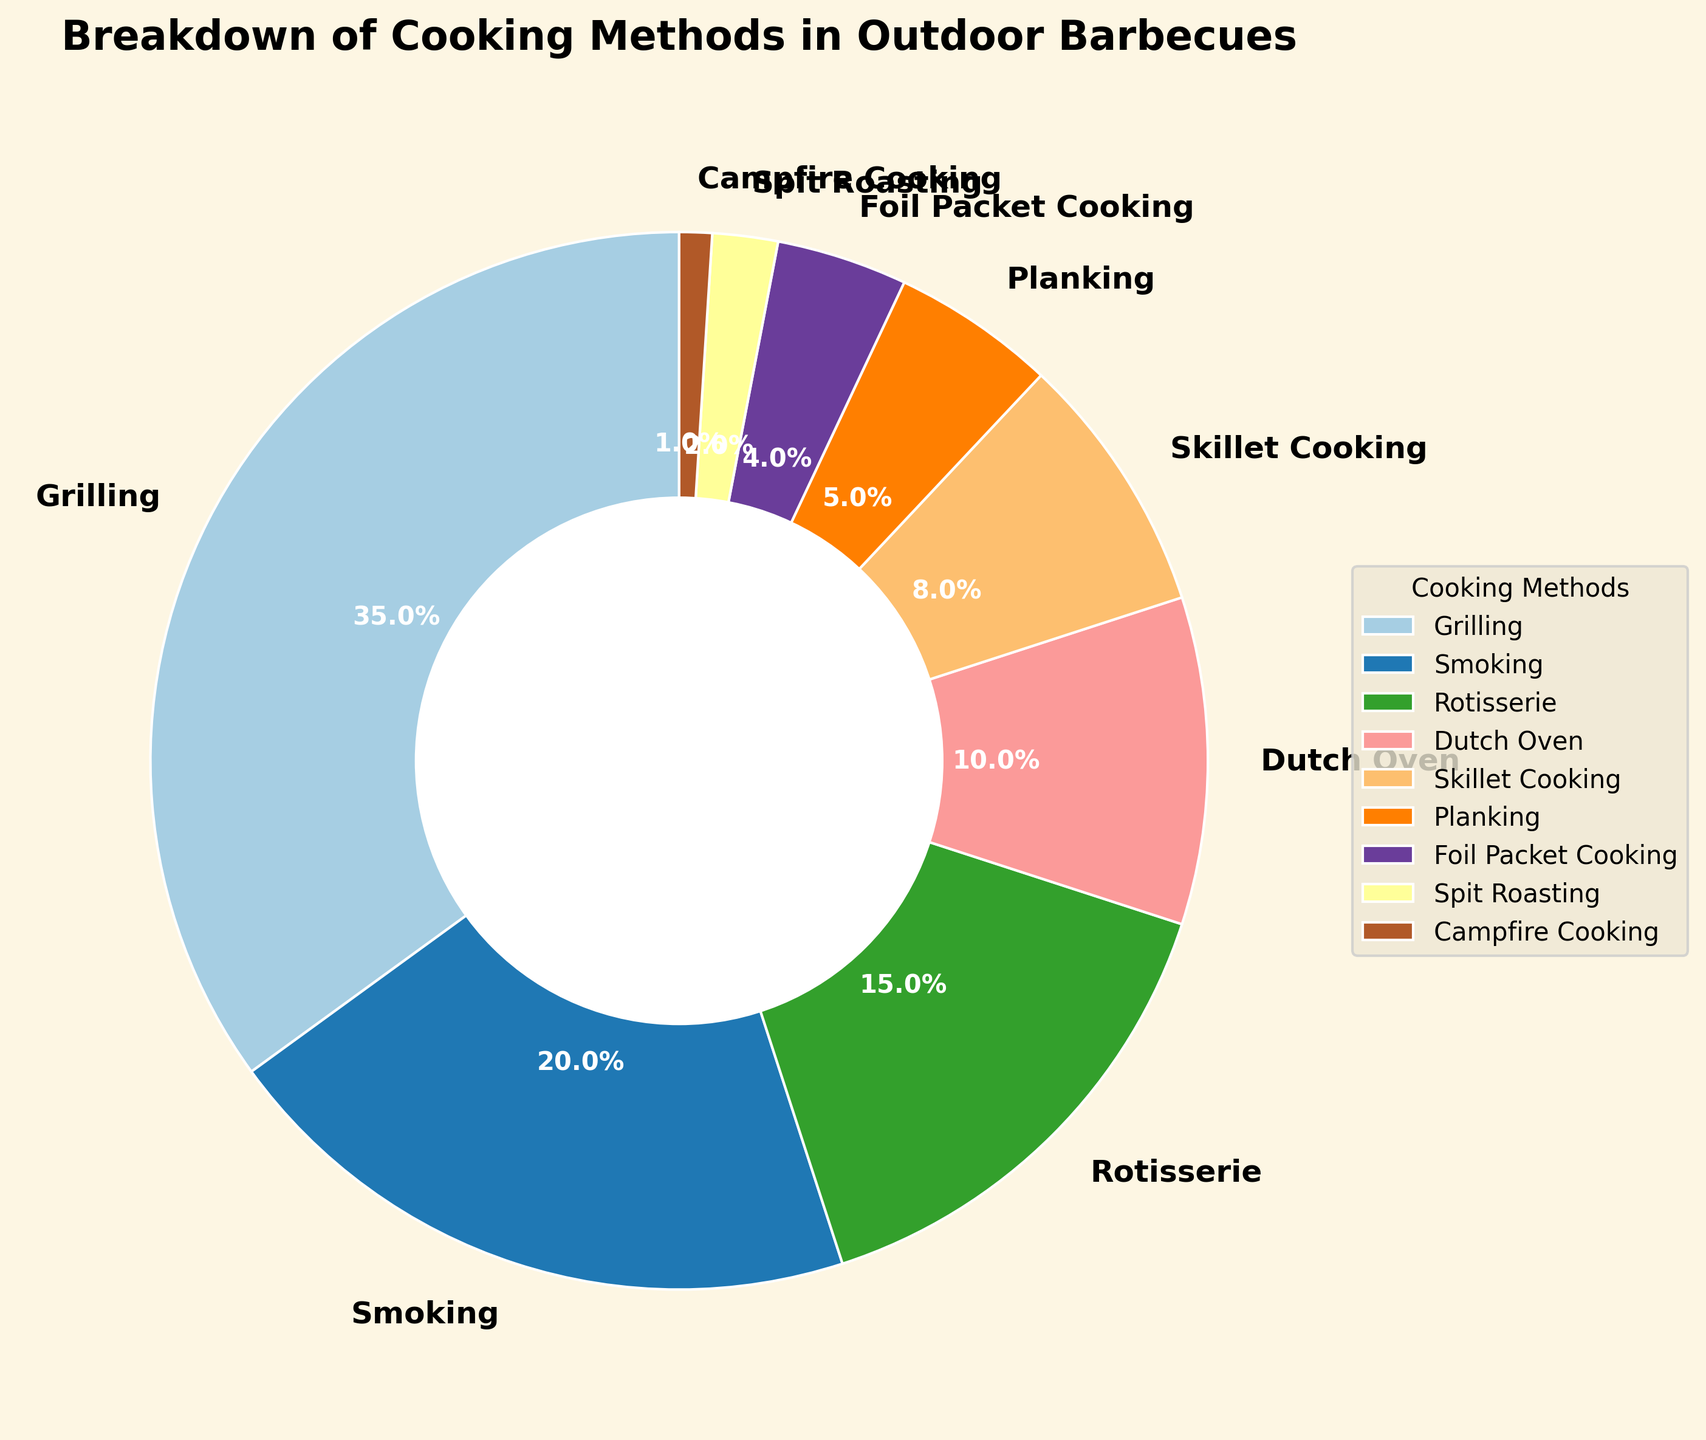Which cooking method is used the most in outdoor barbecues? The cooking method with the largest slice in the pie chart is Grilling, which represents 35%.
Answer: Grilling Which two cooking methods together make up exactly half of the distribution? Summing up the percentages of Grilling (35%) and Smoking (20%) gives us 55%, which exceeds half. Therefore, Grilling (35%) and Rotisserie (15%) together make up exactly 50%.
Answer: Grilling and Rotisserie How much more popular is Grilling than Skillet Cooking? Subtracting the percentage of Skillet Cooking (8%) from Grilling (35%) gives us the difference: 35% - 8% = 27%.
Answer: 27% Which methods each contribute less than 5% to the total distribution? The slices with percentages less than 5% are Planking (5%), Foil Packet Cooking (4%), Spit Roasting (2%), and Campfire Cooking (1%). Since Planking has exactly 5%, it is not included in the answer.
Answer: Foil Packet Cooking, Spit Roasting, Campfire Cooking What is the combined percentage of the three least common cooking methods? Summing up the percentages of Campfire Cooking (1%), Spit Roasting (2%), and Foil Packet Cooking (4%) gives us a total of 1% + 2% + 4% = 7%.
Answer: 7% Which cooking method is just slightly more popular than Planking? Skillet Cooking is 8% and Planking is 5%. The next higher percentage after 5% (Planking) is 8% (Skillet Cooking).
Answer: Skillet Cooking How many cooking methods individually account for more than 10% of the total distribution? The cooking methods with individual percentages greater than 10% are Grilling (35%), Smoking (20%), and Rotisserie (15%).
Answer: 3 What percentage of the total distribution is made up by non-grilling methods? Subtracting the percentage of Grilling (35%) from 100% gives us the total percentage of non-grilling methods: 100% - 35% = 65%.
Answer: 65% What is the percentage difference between Smoking and Dutch Oven? Subtracting the percentage of Dutch Oven (10%) from Smoking (20%) gives us the difference: 20% - 10% = 10%.
Answer: 10% Is the percentage for Planking closer to Foil Packet Cooking or to Skillet Cooking? The percentage for Planking (5%) is closer to Foil Packet Cooking (4%) with a difference of 1%, compared to a difference of 3% with Skillet Cooking (8%).
Answer: Foil Packet Cooking 